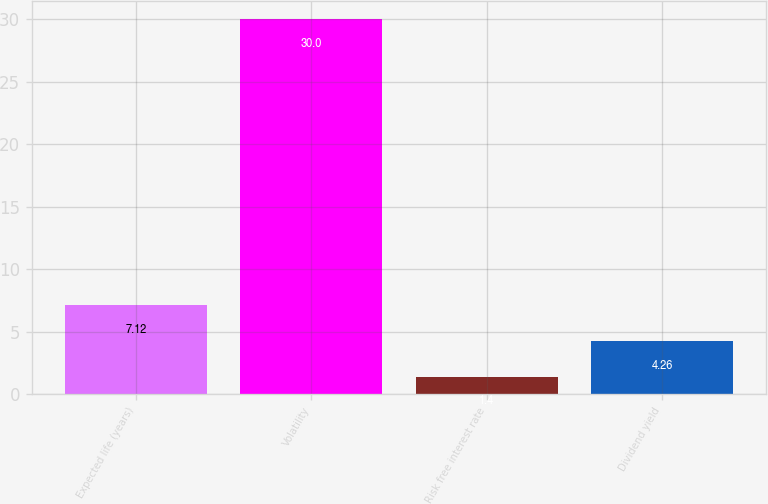Convert chart to OTSL. <chart><loc_0><loc_0><loc_500><loc_500><bar_chart><fcel>Expected life (years)<fcel>Volatility<fcel>Risk free interest rate<fcel>Dividend yield<nl><fcel>7.12<fcel>30<fcel>1.4<fcel>4.26<nl></chart> 